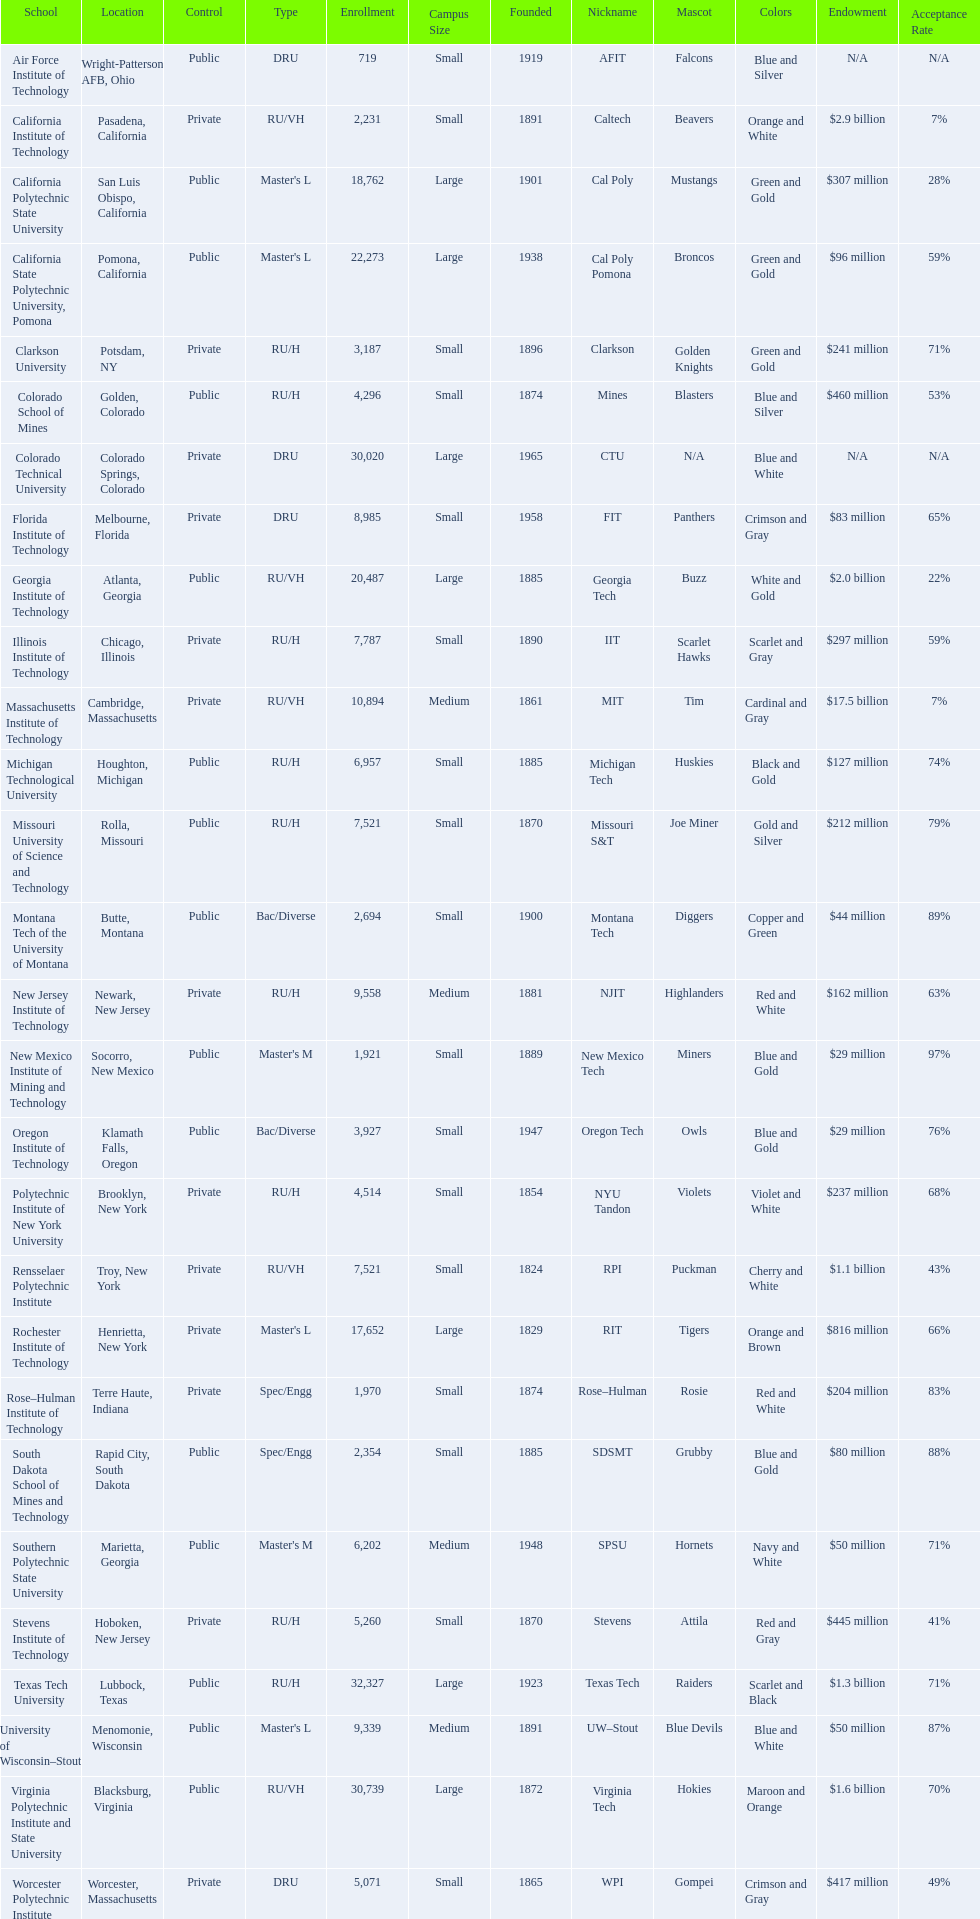What technical universities are in the united states? Air Force Institute of Technology, California Institute of Technology, California Polytechnic State University, California State Polytechnic University, Pomona, Clarkson University, Colorado School of Mines, Colorado Technical University, Florida Institute of Technology, Georgia Institute of Technology, Illinois Institute of Technology, Massachusetts Institute of Technology, Michigan Technological University, Missouri University of Science and Technology, Montana Tech of the University of Montana, New Jersey Institute of Technology, New Mexico Institute of Mining and Technology, Oregon Institute of Technology, Polytechnic Institute of New York University, Rensselaer Polytechnic Institute, Rochester Institute of Technology, Rose–Hulman Institute of Technology, South Dakota School of Mines and Technology, Southern Polytechnic State University, Stevens Institute of Technology, Texas Tech University, University of Wisconsin–Stout, Virginia Polytechnic Institute and State University, Worcester Polytechnic Institute. Which has the highest enrollment? Texas Tech University. 